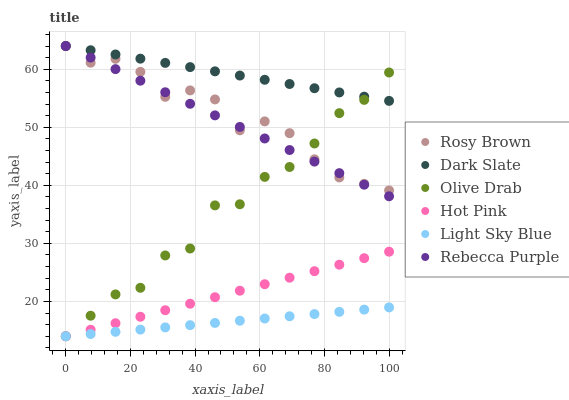Does Light Sky Blue have the minimum area under the curve?
Answer yes or no. Yes. Does Dark Slate have the maximum area under the curve?
Answer yes or no. Yes. Does Rosy Brown have the minimum area under the curve?
Answer yes or no. No. Does Rosy Brown have the maximum area under the curve?
Answer yes or no. No. Is Light Sky Blue the smoothest?
Answer yes or no. Yes. Is Olive Drab the roughest?
Answer yes or no. Yes. Is Rosy Brown the smoothest?
Answer yes or no. No. Is Rosy Brown the roughest?
Answer yes or no. No. Does Hot Pink have the lowest value?
Answer yes or no. Yes. Does Rosy Brown have the lowest value?
Answer yes or no. No. Does Rebecca Purple have the highest value?
Answer yes or no. Yes. Does Light Sky Blue have the highest value?
Answer yes or no. No. Is Light Sky Blue less than Dark Slate?
Answer yes or no. Yes. Is Rosy Brown greater than Hot Pink?
Answer yes or no. Yes. Does Olive Drab intersect Rosy Brown?
Answer yes or no. Yes. Is Olive Drab less than Rosy Brown?
Answer yes or no. No. Is Olive Drab greater than Rosy Brown?
Answer yes or no. No. Does Light Sky Blue intersect Dark Slate?
Answer yes or no. No. 